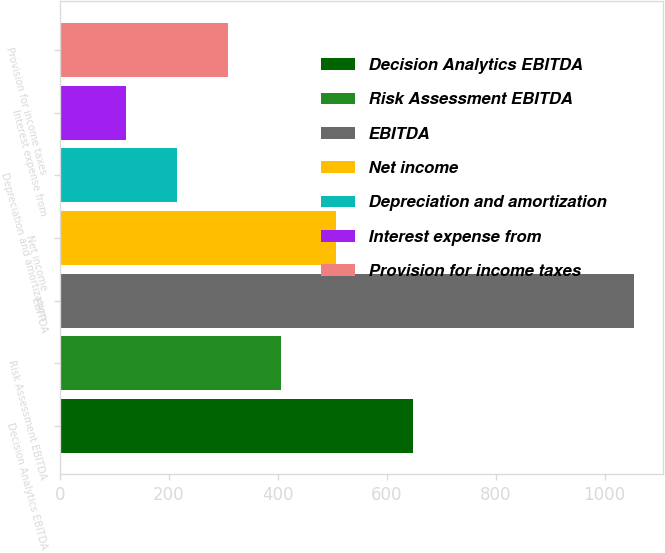<chart> <loc_0><loc_0><loc_500><loc_500><bar_chart><fcel>Decision Analytics EBITDA<fcel>Risk Assessment EBITDA<fcel>EBITDA<fcel>Net income<fcel>Depreciation and amortization<fcel>Interest expense from<fcel>Provision for income taxes<nl><fcel>647.7<fcel>406.5<fcel>1054.2<fcel>507.6<fcel>214.68<fcel>121.4<fcel>307.96<nl></chart> 